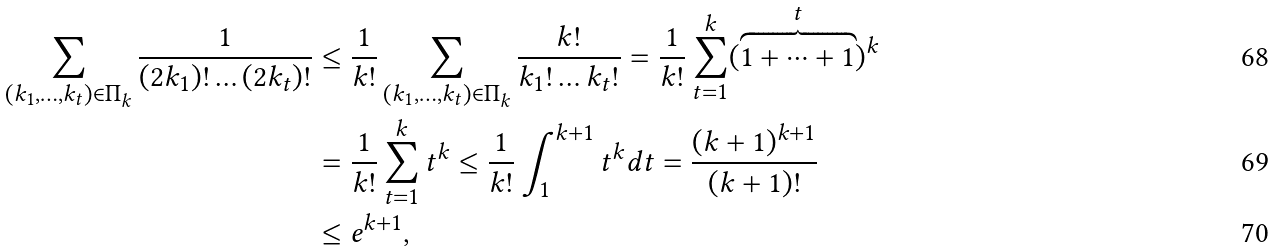Convert formula to latex. <formula><loc_0><loc_0><loc_500><loc_500>\sum _ { ( k _ { 1 } , \dots , k _ { t } ) \in \Pi _ { k } } \frac { 1 } { ( 2 k _ { 1 } ) ! \dots ( 2 k _ { t } ) ! } & \leq \frac { 1 } { k ! } \sum _ { ( k _ { 1 } , \dots , k _ { t } ) \in \Pi _ { k } } \frac { k ! } { k _ { 1 } ! \dots k _ { t } ! } = \frac { 1 } { k ! } \sum _ { t = 1 } ^ { k } ( \overbrace { 1 + \dots + 1 } ^ { t } ) ^ { k } \\ & = \frac { 1 } { k ! } \sum _ { t = 1 } ^ { k } t ^ { k } \leq \frac { 1 } { k ! } \int _ { 1 } ^ { k + 1 } t ^ { k } d t = \frac { ( k + 1 ) ^ { k + 1 } } { ( k + 1 ) ! } \\ & \leq e ^ { k + 1 } ,</formula> 